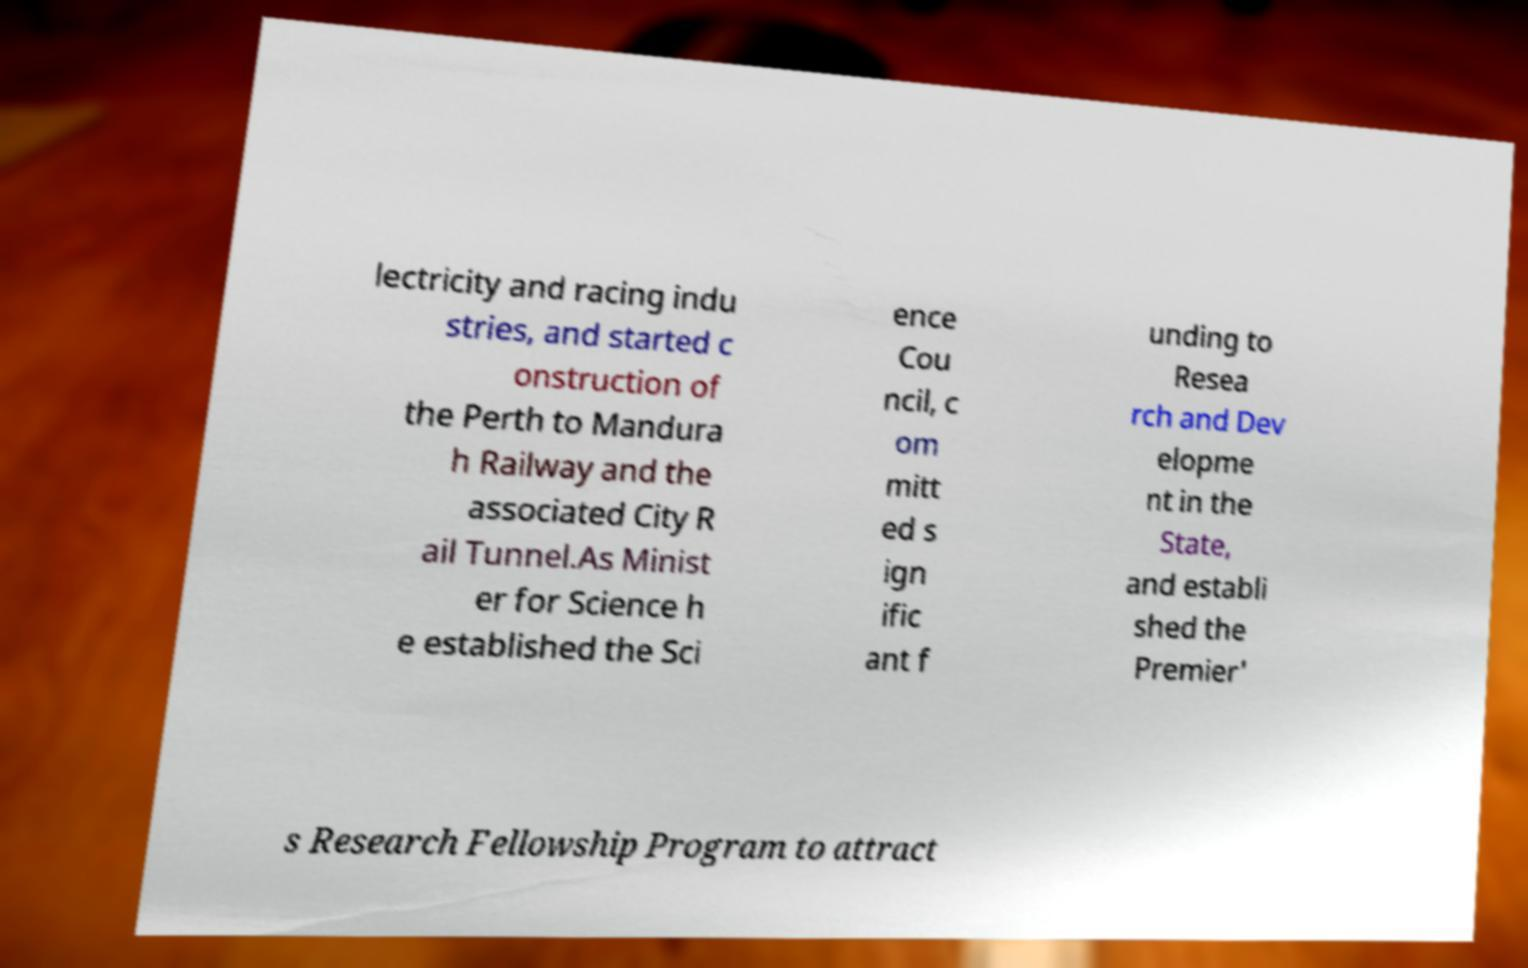For documentation purposes, I need the text within this image transcribed. Could you provide that? lectricity and racing indu stries, and started c onstruction of the Perth to Mandura h Railway and the associated City R ail Tunnel.As Minist er for Science h e established the Sci ence Cou ncil, c om mitt ed s ign ific ant f unding to Resea rch and Dev elopme nt in the State, and establi shed the Premier' s Research Fellowship Program to attract 